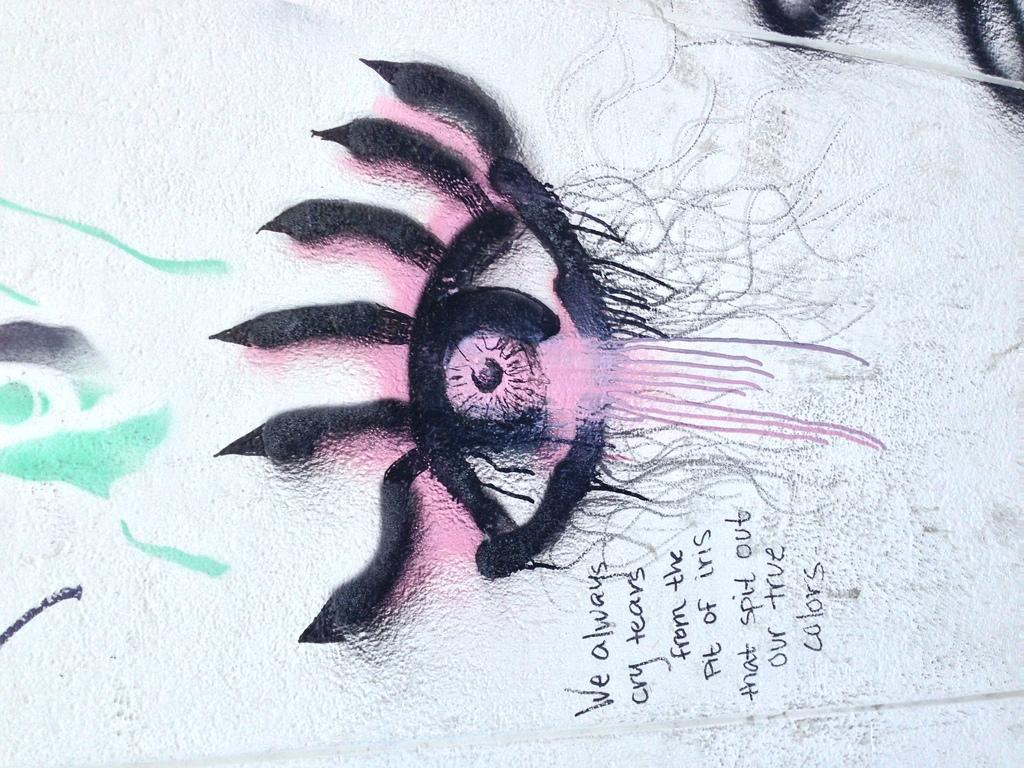What type of artwork is depicted in the image? The image appears to be a painting. What color is the background of the painting? The painting has a white background. Is there any text present in the painting? Yes, there is text at the bottom of the painting. What sign is the father holding in the painting? There is no sign or father present in the painting; it only has a white background and text at the bottom. 